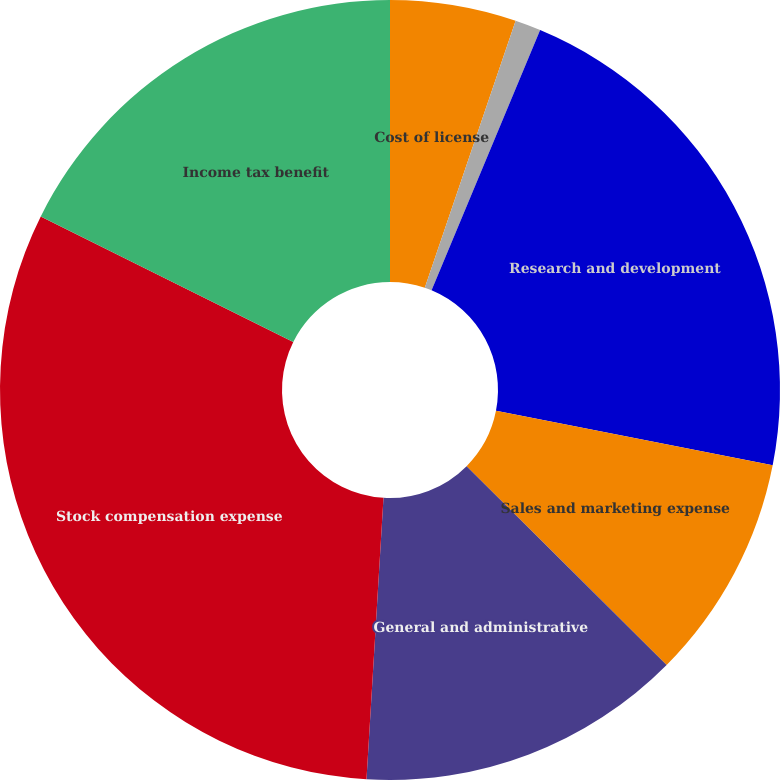Convert chart. <chart><loc_0><loc_0><loc_500><loc_500><pie_chart><fcel>Cost of license<fcel>Cost of maintenance and<fcel>Research and development<fcel>Sales and marketing expense<fcel>General and administrative<fcel>Stock compensation expense<fcel>Income tax benefit<nl><fcel>5.22%<fcel>1.07%<fcel>21.8%<fcel>9.36%<fcel>13.51%<fcel>31.38%<fcel>17.66%<nl></chart> 